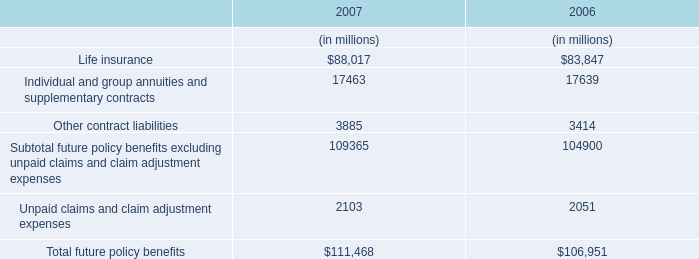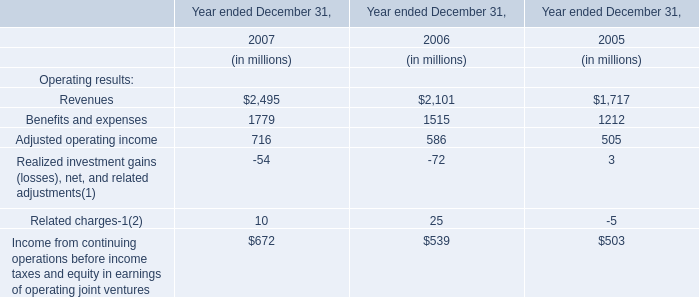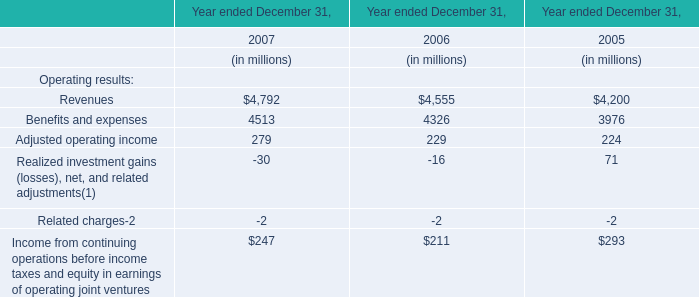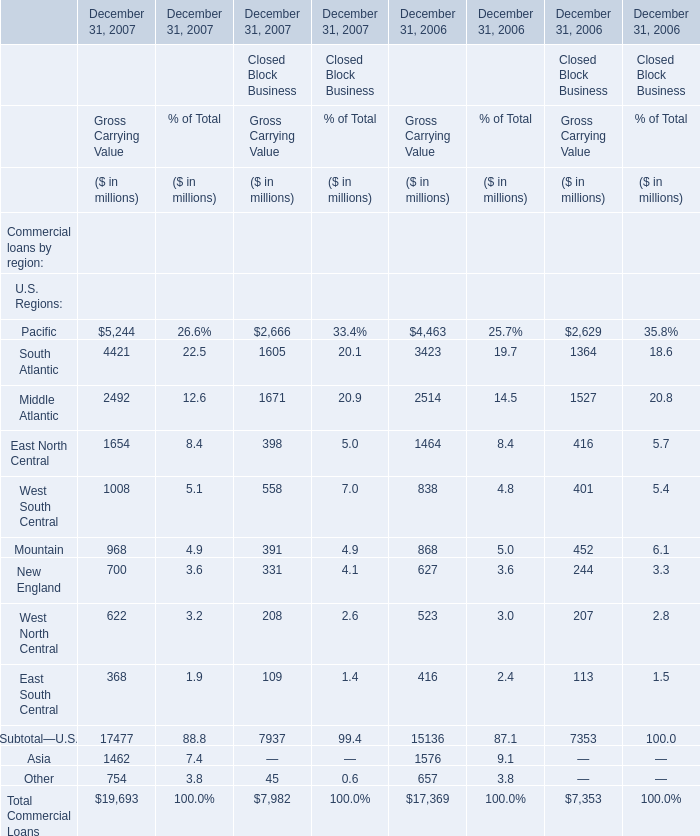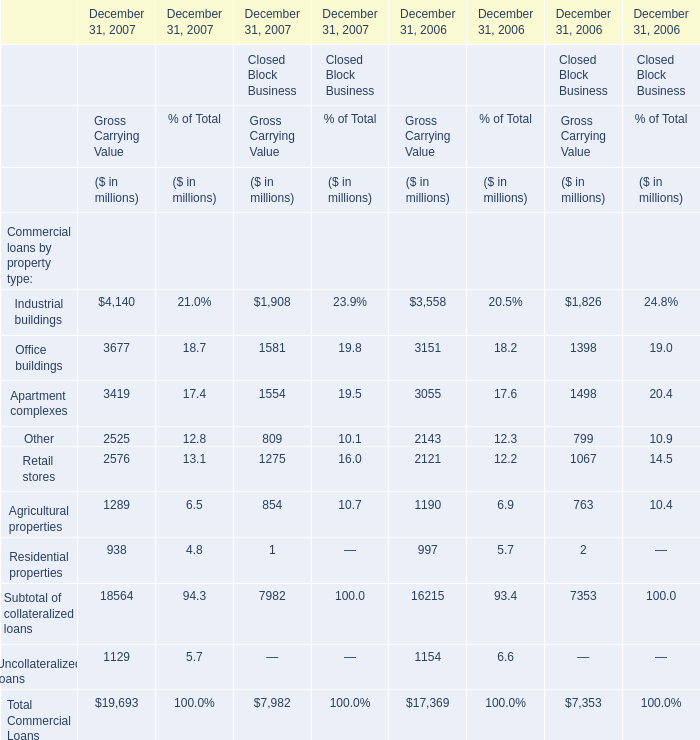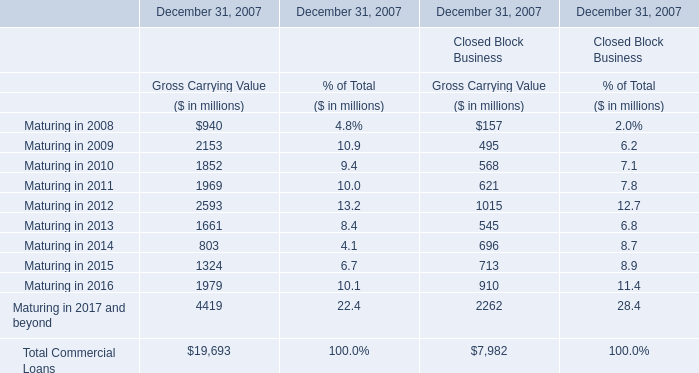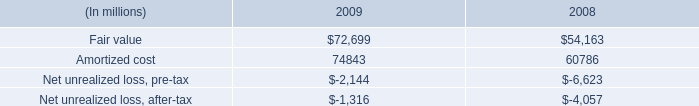What was the average of Gross Carrying Value in 2008,2009 and 2010 for Gross Carrying Value? (in million) 
Computations: (((940 + 2153) + 1852) / 3)
Answer: 1648.33333. 